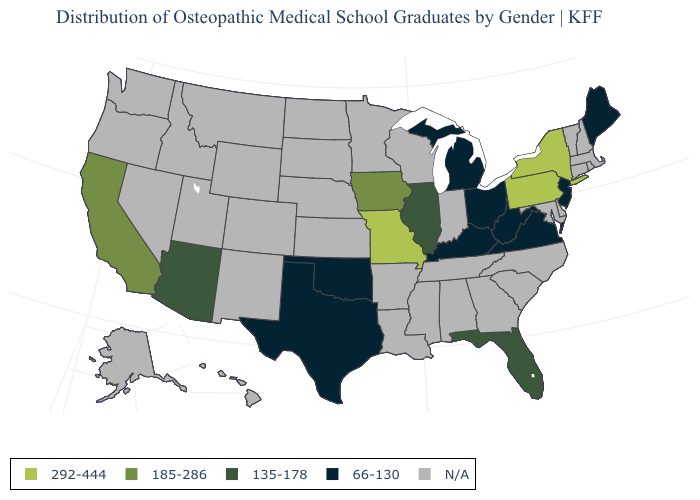What is the value of Hawaii?
Short answer required. N/A. What is the highest value in the MidWest ?
Be succinct. 292-444. Is the legend a continuous bar?
Keep it brief. No. Does Arizona have the highest value in the West?
Write a very short answer. No. What is the value of West Virginia?
Answer briefly. 66-130. What is the value of Utah?
Give a very brief answer. N/A. What is the highest value in the USA?
Short answer required. 292-444. Does the first symbol in the legend represent the smallest category?
Give a very brief answer. No. Name the states that have a value in the range 185-286?
Concise answer only. California, Iowa. Name the states that have a value in the range 292-444?
Concise answer only. Missouri, New York, Pennsylvania. 